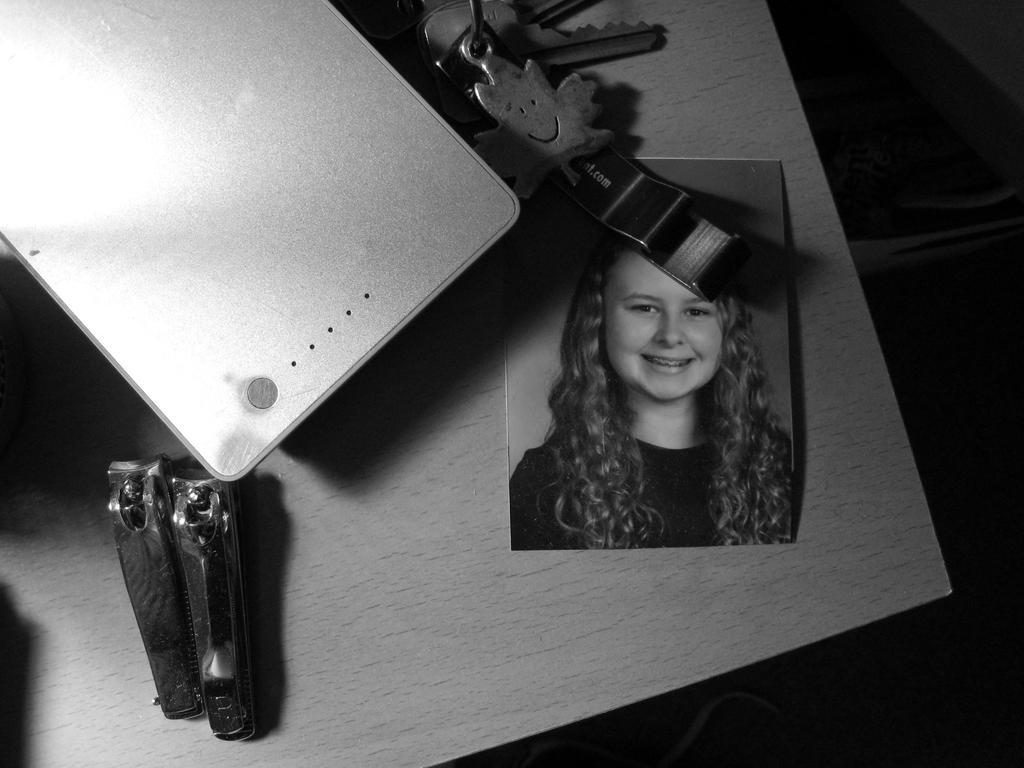Describe this image in one or two sentences. In this image on the table there is a photograph, two nail cutters and some other objects. 